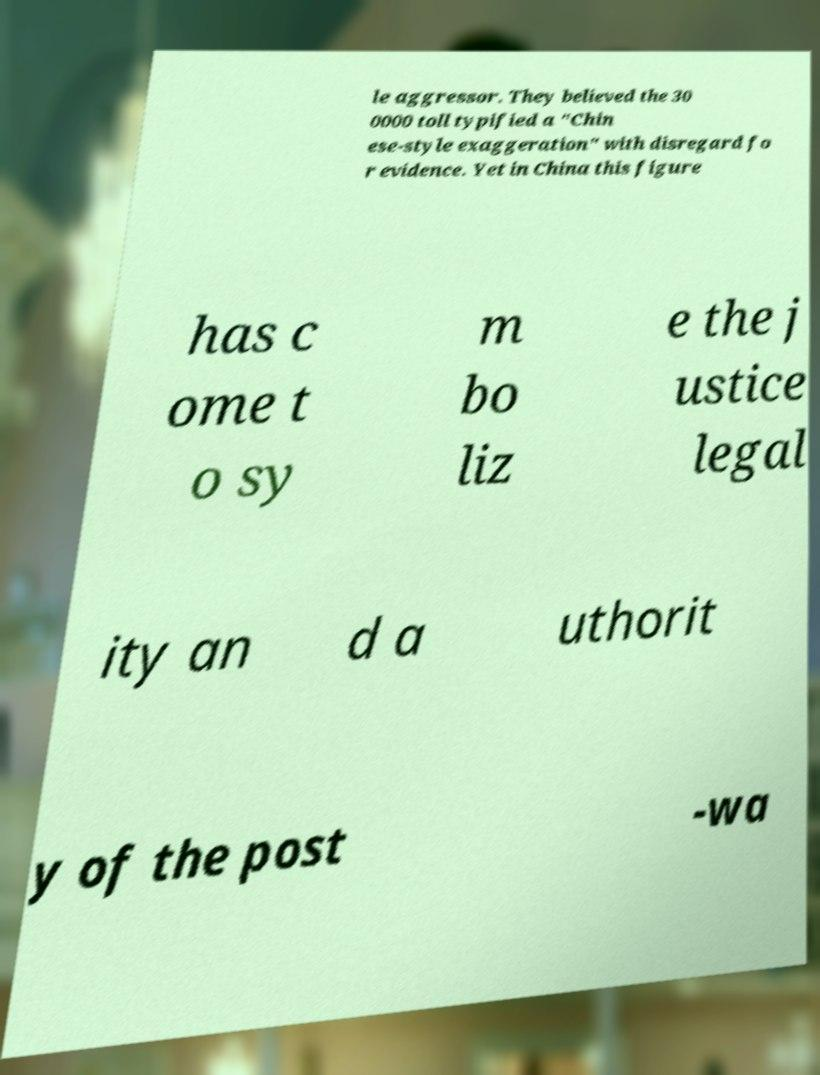I need the written content from this picture converted into text. Can you do that? le aggressor. They believed the 30 0000 toll typified a "Chin ese-style exaggeration" with disregard fo r evidence. Yet in China this figure has c ome t o sy m bo liz e the j ustice legal ity an d a uthorit y of the post -wa 